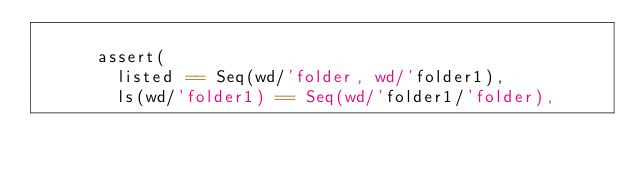<code> <loc_0><loc_0><loc_500><loc_500><_Scala_>
      assert(
        listed == Seq(wd/'folder, wd/'folder1),
        ls(wd/'folder1) == Seq(wd/'folder1/'folder),</code> 